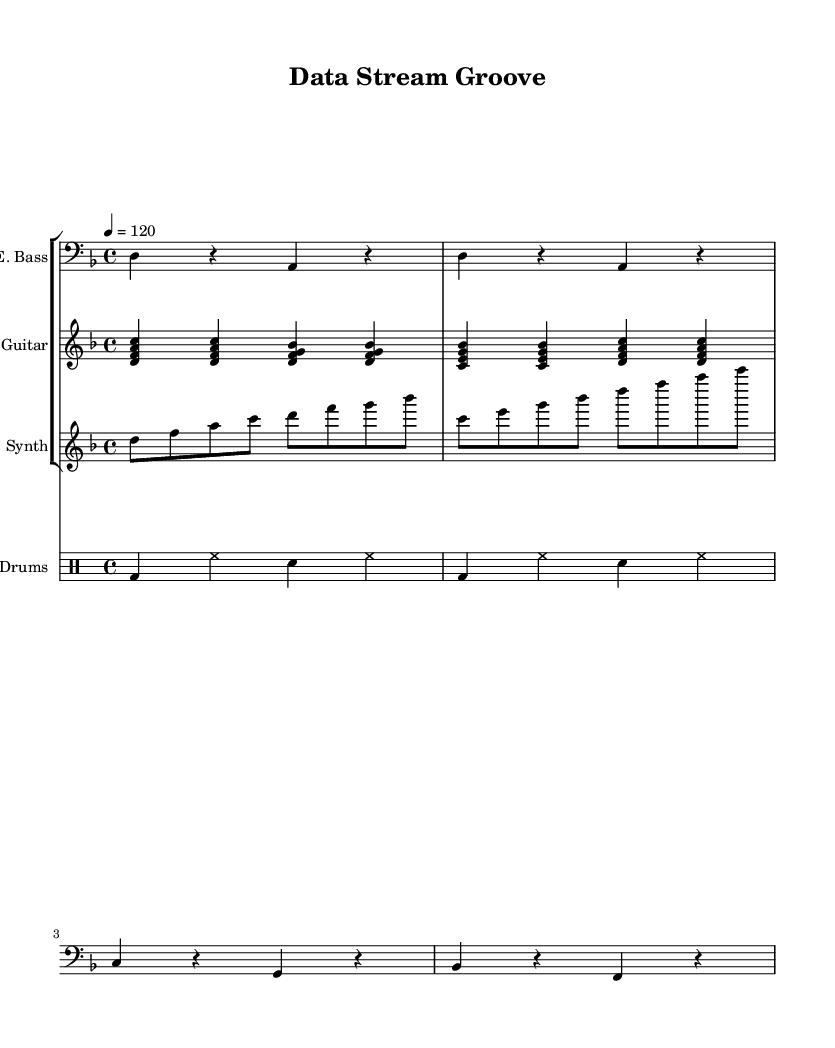What is the key signature of this music? The key signature is indicated at the beginning of the score. In this case, it shows one flat, which signifies that the piece is in D minor.
Answer: D minor What is the time signature of this piece? The time signature is also located at the beginning of the score and is indicated as 4/4, meaning there are four beats per measure and a quarter note gets one beat.
Answer: 4/4 What is the tempo marking? The tempo is specified in beats per minute (BPM), which is indicated as 120 at the start of the score. This means the music should be played at 120 beats per minute.
Answer: 120 How many measures are in the electric bass part? By counting the distinct segments in the electric bass part, there are a total of four measures visible in the provided sheet music.
Answer: 4 What are the first four notes of the synthesizer part? The notes are listed in order at the beginning of the synthesizer line. They are D, F, A, and C, which are the first four notes played.
Answer: D, F, A, C Which instruments are included in this score? By observing the score layout, the instruments listed are Electric Bass, Electric Guitar, Synthesizer, and Drums.
Answer: Electric Bass, Electric Guitar, Synthesizer, Drums What type of musical fusion is represented in this score? The piece integrates various musical elements, using real-time data streams as inspirations for musical creativity, fitting squarely in the genre of funk fusion.
Answer: Funk Fusion 